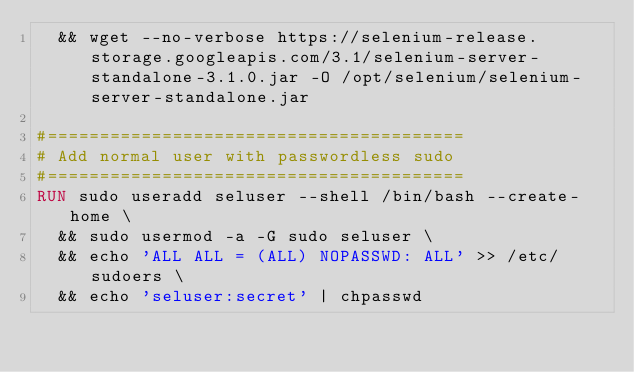Convert code to text. <code><loc_0><loc_0><loc_500><loc_500><_Dockerfile_>  && wget --no-verbose https://selenium-release.storage.googleapis.com/3.1/selenium-server-standalone-3.1.0.jar -O /opt/selenium/selenium-server-standalone.jar

#========================================
# Add normal user with passwordless sudo
#========================================
RUN sudo useradd seluser --shell /bin/bash --create-home \
  && sudo usermod -a -G sudo seluser \
  && echo 'ALL ALL = (ALL) NOPASSWD: ALL' >> /etc/sudoers \
  && echo 'seluser:secret' | chpasswd
</code> 